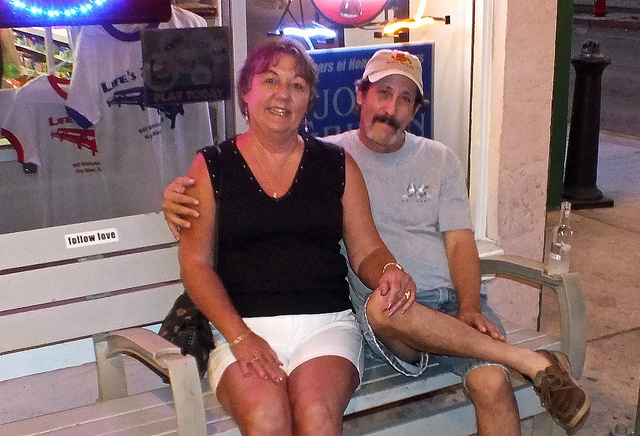Identify the text displayed in this image. lollow Love LIE'S 